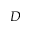<formula> <loc_0><loc_0><loc_500><loc_500>D</formula> 